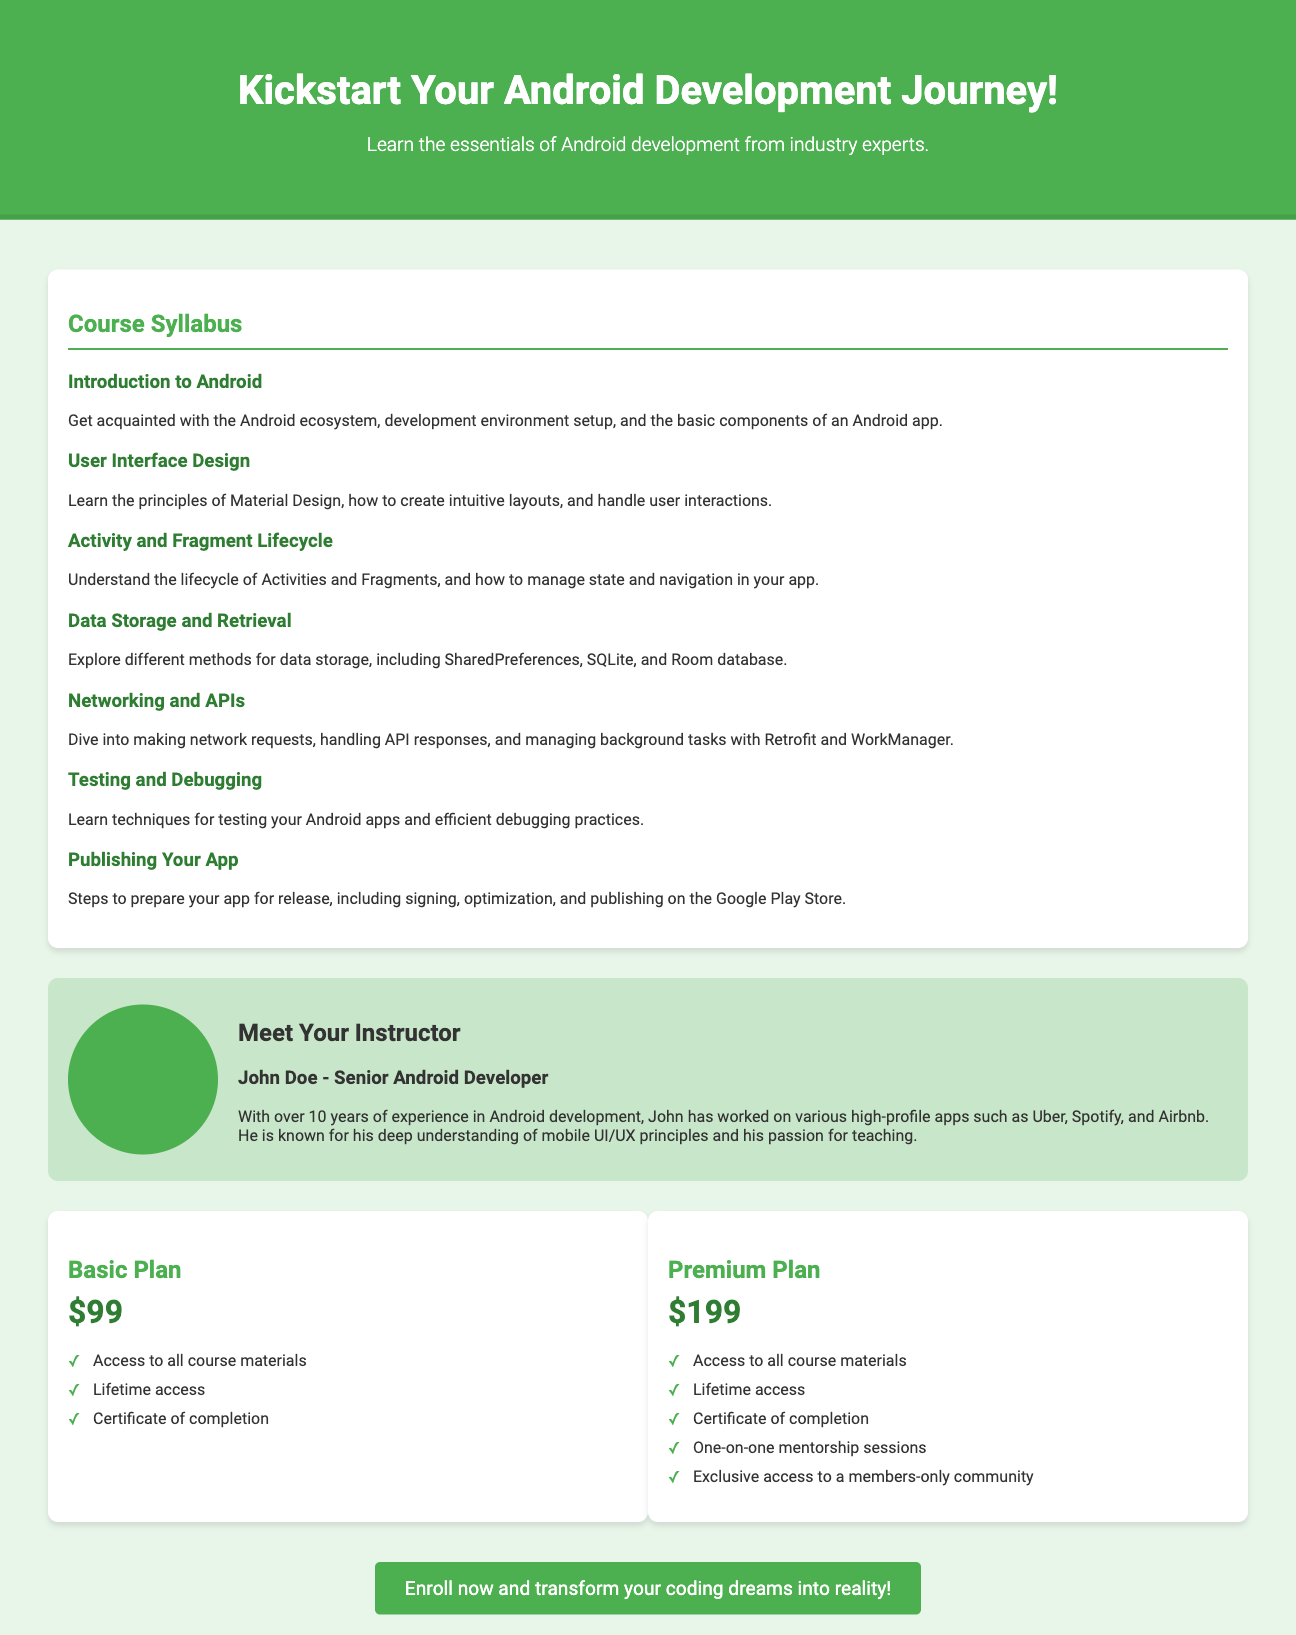What is the course price for the Basic Plan? The Basic Plan's price is explicitly stated in the document, which is $99.
Answer: $99 Who is the instructor of the course? The document clearly mentions the instructor's name, which is John Doe.
Answer: John Doe How many years of experience does the instructor have? The instructor's experience is mentioned in the document, which states he has over 10 years of experience.
Answer: 10 years What is included in the Premium Plan? The document lists the features included in the Premium Plan, such as one-on-one mentorship sessions and exclusive access to a community.
Answer: One-on-one mentorship sessions What topic covers getting acquainted with basic components of an Android app? The syllabus item that corresponds to this information is "Introduction to Android."
Answer: Introduction to Android What feature is available for both plans mentioned? Both plans provide access to all course materials and lifetime access as stated in the document.
Answer: Access to all course materials How many syllabus topics are listed in the course? The syllabus section contains seven distinct topics covering various aspects of Android development.
Answer: Seven What is the tagline of the course? The tagline is specified beneath the course title, highlighting the core message of the advertisement.
Answer: Learn the essentials of Android development from industry experts 